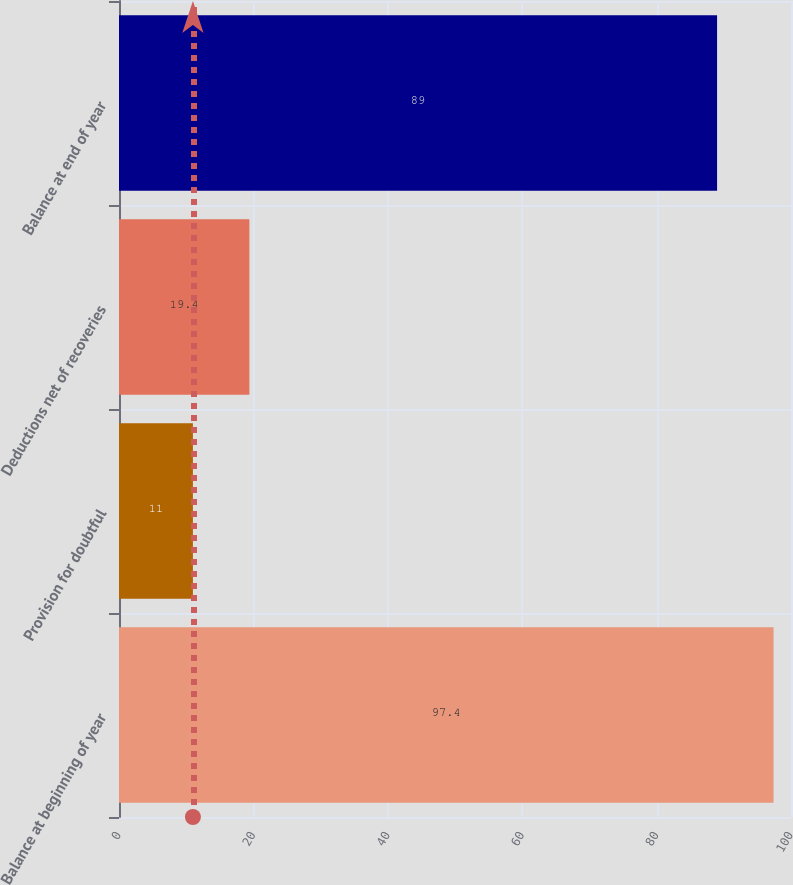<chart> <loc_0><loc_0><loc_500><loc_500><bar_chart><fcel>Balance at beginning of year<fcel>Provision for doubtful<fcel>Deductions net of recoveries<fcel>Balance at end of year<nl><fcel>97.4<fcel>11<fcel>19.4<fcel>89<nl></chart> 